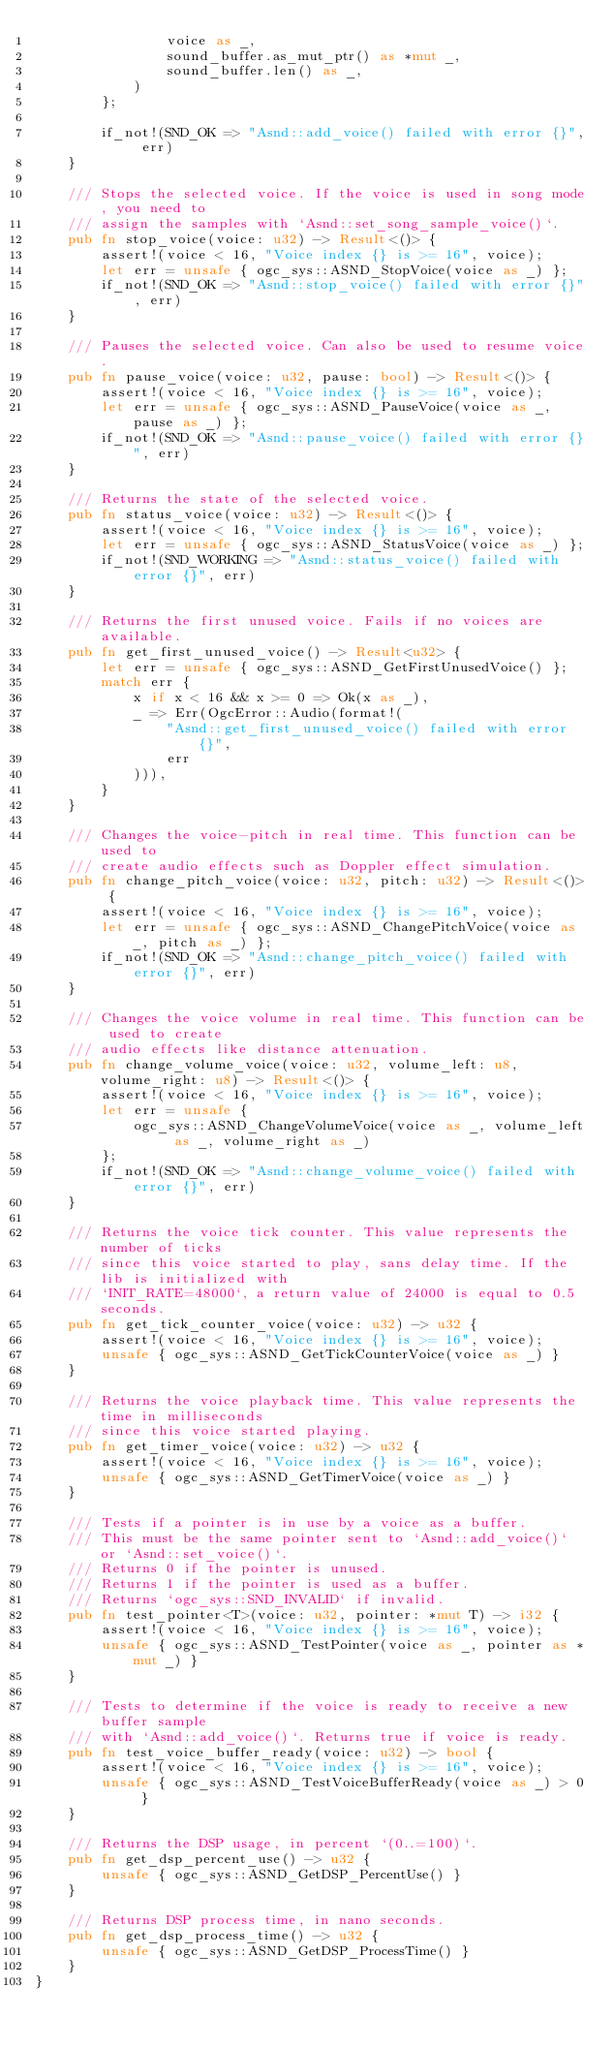Convert code to text. <code><loc_0><loc_0><loc_500><loc_500><_Rust_>                voice as _,
                sound_buffer.as_mut_ptr() as *mut _,
                sound_buffer.len() as _,
            )
        };

        if_not!(SND_OK => "Asnd::add_voice() failed with error {}", err)
    }

    /// Stops the selected voice. If the voice is used in song mode, you need to
    /// assign the samples with `Asnd::set_song_sample_voice()`.
    pub fn stop_voice(voice: u32) -> Result<()> {
        assert!(voice < 16, "Voice index {} is >= 16", voice);
        let err = unsafe { ogc_sys::ASND_StopVoice(voice as _) };
        if_not!(SND_OK => "Asnd::stop_voice() failed with error {}", err)
    }

    /// Pauses the selected voice. Can also be used to resume voice.
    pub fn pause_voice(voice: u32, pause: bool) -> Result<()> {
        assert!(voice < 16, "Voice index {} is >= 16", voice);
        let err = unsafe { ogc_sys::ASND_PauseVoice(voice as _, pause as _) };
        if_not!(SND_OK => "Asnd::pause_voice() failed with error {}", err)
    }

    /// Returns the state of the selected voice.
    pub fn status_voice(voice: u32) -> Result<()> {
        assert!(voice < 16, "Voice index {} is >= 16", voice);
        let err = unsafe { ogc_sys::ASND_StatusVoice(voice as _) };
        if_not!(SND_WORKING => "Asnd::status_voice() failed with error {}", err)
    }

    /// Returns the first unused voice. Fails if no voices are available.
    pub fn get_first_unused_voice() -> Result<u32> {
        let err = unsafe { ogc_sys::ASND_GetFirstUnusedVoice() };
        match err {
            x if x < 16 && x >= 0 => Ok(x as _),
            _ => Err(OgcError::Audio(format!(
                "Asnd::get_first_unused_voice() failed with error {}",
                err
            ))),
        }
    }

    /// Changes the voice-pitch in real time. This function can be used to
    /// create audio effects such as Doppler effect simulation.
    pub fn change_pitch_voice(voice: u32, pitch: u32) -> Result<()> {
        assert!(voice < 16, "Voice index {} is >= 16", voice);
        let err = unsafe { ogc_sys::ASND_ChangePitchVoice(voice as _, pitch as _) };
        if_not!(SND_OK => "Asnd::change_pitch_voice() failed with error {}", err)
    }

    /// Changes the voice volume in real time. This function can be used to create
    /// audio effects like distance attenuation.
    pub fn change_volume_voice(voice: u32, volume_left: u8, volume_right: u8) -> Result<()> {
        assert!(voice < 16, "Voice index {} is >= 16", voice);
        let err = unsafe {
            ogc_sys::ASND_ChangeVolumeVoice(voice as _, volume_left as _, volume_right as _)
        };
        if_not!(SND_OK => "Asnd::change_volume_voice() failed with error {}", err)
    }

    /// Returns the voice tick counter. This value represents the number of ticks
    /// since this voice started to play, sans delay time. If the lib is initialized with
    /// `INIT_RATE=48000`, a return value of 24000 is equal to 0.5 seconds.
    pub fn get_tick_counter_voice(voice: u32) -> u32 {
        assert!(voice < 16, "Voice index {} is >= 16", voice);
        unsafe { ogc_sys::ASND_GetTickCounterVoice(voice as _) }
    }

    /// Returns the voice playback time. This value represents the time in milliseconds
    /// since this voice started playing.
    pub fn get_timer_voice(voice: u32) -> u32 {
        assert!(voice < 16, "Voice index {} is >= 16", voice);
        unsafe { ogc_sys::ASND_GetTimerVoice(voice as _) }
    }

    /// Tests if a pointer is in use by a voice as a buffer.
    /// This must be the same pointer sent to `Asnd::add_voice()` or `Asnd::set_voice()`.
    /// Returns 0 if the pointer is unused.
    /// Returns 1 if the pointer is used as a buffer.
    /// Returns `ogc_sys::SND_INVALID` if invalid.
    pub fn test_pointer<T>(voice: u32, pointer: *mut T) -> i32 {
        assert!(voice < 16, "Voice index {} is >= 16", voice);
        unsafe { ogc_sys::ASND_TestPointer(voice as _, pointer as *mut _) }
    }

    /// Tests to determine if the voice is ready to receive a new buffer sample
    /// with `Asnd::add_voice()`. Returns true if voice is ready.
    pub fn test_voice_buffer_ready(voice: u32) -> bool {
        assert!(voice < 16, "Voice index {} is >= 16", voice);
        unsafe { ogc_sys::ASND_TestVoiceBufferReady(voice as _) > 0 }
    }

    /// Returns the DSP usage, in percent `(0..=100)`.
    pub fn get_dsp_percent_use() -> u32 {
        unsafe { ogc_sys::ASND_GetDSP_PercentUse() }
    }

    /// Returns DSP process time, in nano seconds.
    pub fn get_dsp_process_time() -> u32 {
        unsafe { ogc_sys::ASND_GetDSP_ProcessTime() }
    }
}
</code> 